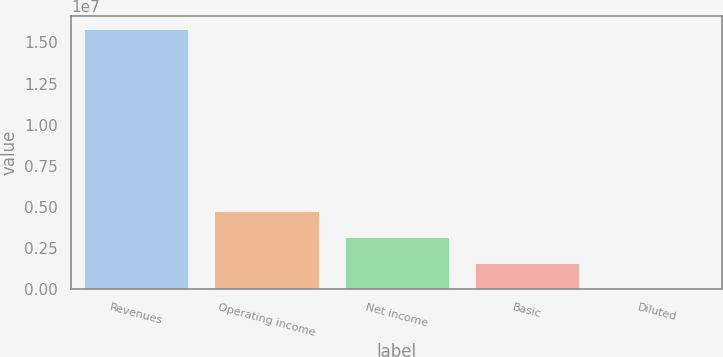Convert chart. <chart><loc_0><loc_0><loc_500><loc_500><bar_chart><fcel>Revenues<fcel>Operating income<fcel>Net income<fcel>Basic<fcel>Diluted<nl><fcel>1.57943e+07<fcel>4.7383e+06<fcel>3.15887e+06<fcel>1.57944e+06<fcel>2.68<nl></chart> 